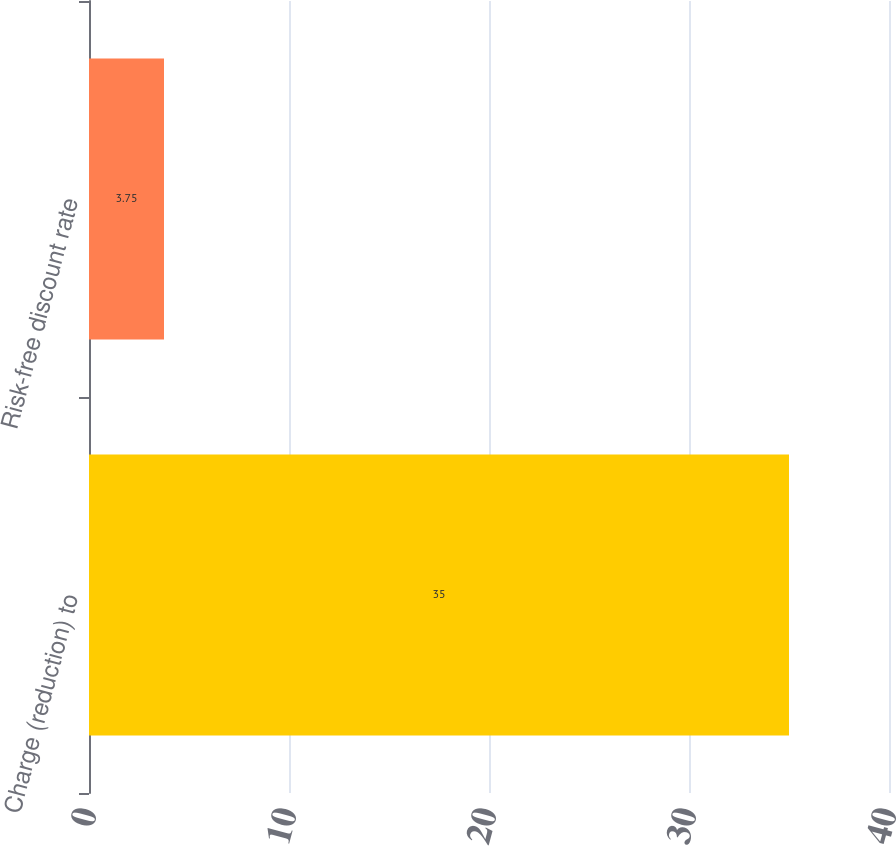Convert chart to OTSL. <chart><loc_0><loc_0><loc_500><loc_500><bar_chart><fcel>Charge (reduction) to<fcel>Risk-free discount rate<nl><fcel>35<fcel>3.75<nl></chart> 